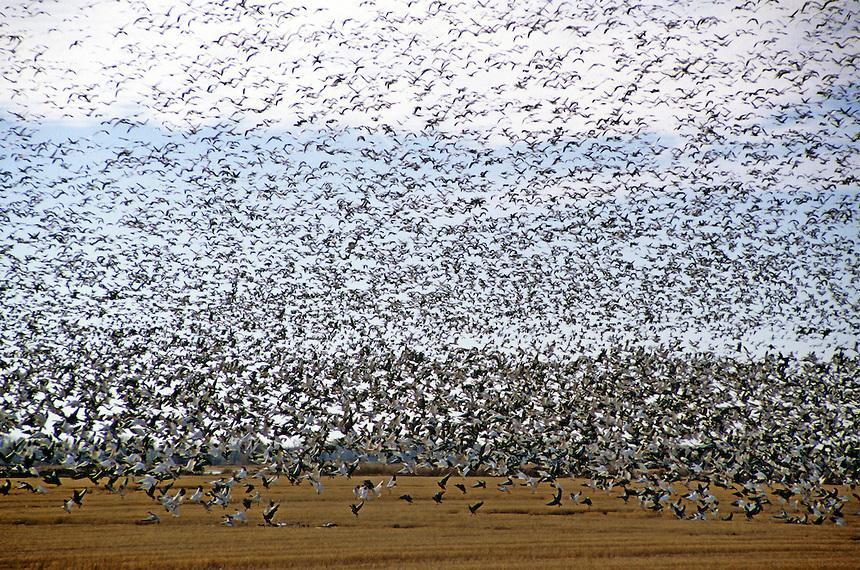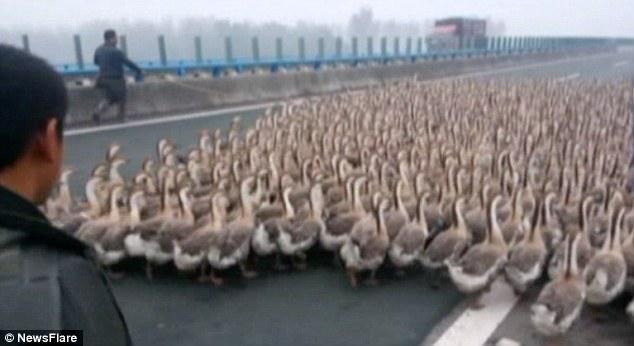The first image is the image on the left, the second image is the image on the right. Evaluate the accuracy of this statement regarding the images: "An image contains a person facing a large group of ducks,". Is it true? Answer yes or no. Yes. 